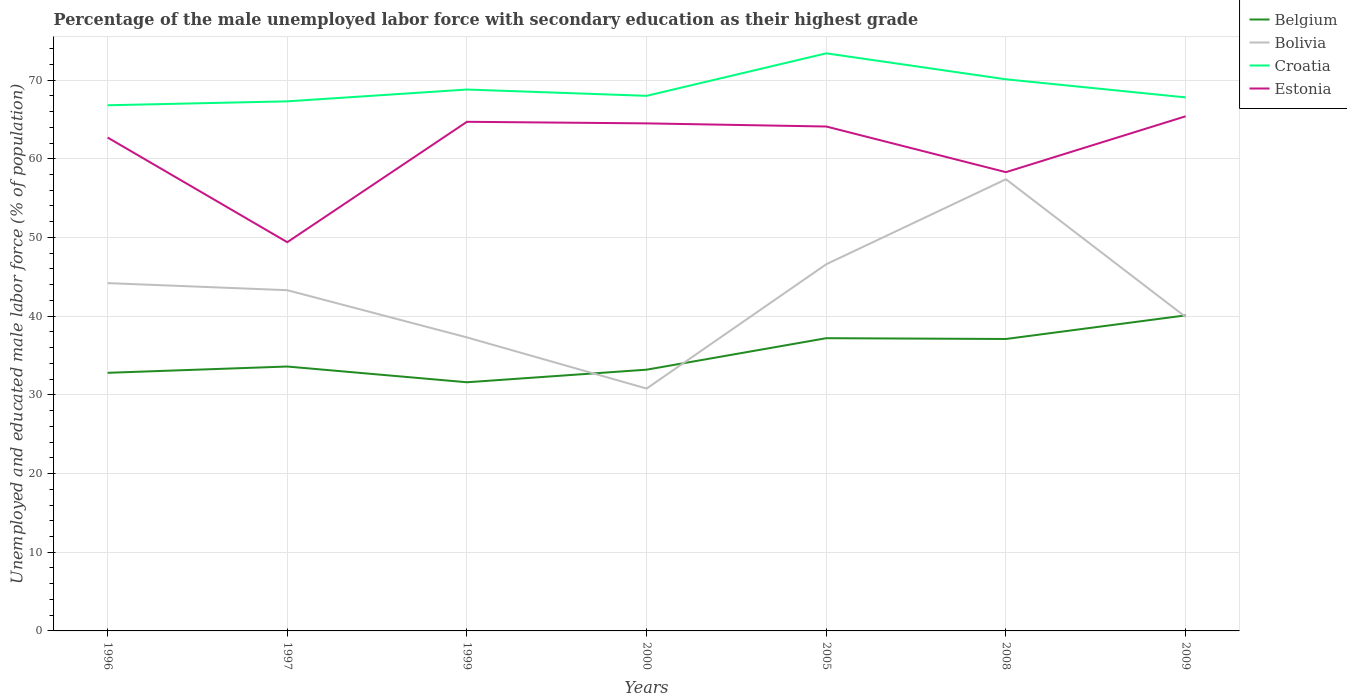Does the line corresponding to Estonia intersect with the line corresponding to Bolivia?
Keep it short and to the point. No. Across all years, what is the maximum percentage of the unemployed male labor force with secondary education in Bolivia?
Ensure brevity in your answer.  30.8. In which year was the percentage of the unemployed male labor force with secondary education in Belgium maximum?
Keep it short and to the point. 1999. What is the total percentage of the unemployed male labor force with secondary education in Belgium in the graph?
Keep it short and to the point. -7.3. What is the difference between the highest and the second highest percentage of the unemployed male labor force with secondary education in Bolivia?
Keep it short and to the point. 26.6. Is the percentage of the unemployed male labor force with secondary education in Belgium strictly greater than the percentage of the unemployed male labor force with secondary education in Croatia over the years?
Keep it short and to the point. Yes. How many lines are there?
Your answer should be compact. 4. How many years are there in the graph?
Provide a succinct answer. 7. What is the difference between two consecutive major ticks on the Y-axis?
Offer a very short reply. 10. What is the title of the graph?
Give a very brief answer. Percentage of the male unemployed labor force with secondary education as their highest grade. Does "Israel" appear as one of the legend labels in the graph?
Make the answer very short. No. What is the label or title of the Y-axis?
Keep it short and to the point. Unemployed and educated male labor force (% of population). What is the Unemployed and educated male labor force (% of population) of Belgium in 1996?
Your answer should be very brief. 32.8. What is the Unemployed and educated male labor force (% of population) in Bolivia in 1996?
Provide a short and direct response. 44.2. What is the Unemployed and educated male labor force (% of population) of Croatia in 1996?
Your answer should be very brief. 66.8. What is the Unemployed and educated male labor force (% of population) of Estonia in 1996?
Provide a succinct answer. 62.7. What is the Unemployed and educated male labor force (% of population) of Belgium in 1997?
Your response must be concise. 33.6. What is the Unemployed and educated male labor force (% of population) in Bolivia in 1997?
Offer a very short reply. 43.3. What is the Unemployed and educated male labor force (% of population) of Croatia in 1997?
Keep it short and to the point. 67.3. What is the Unemployed and educated male labor force (% of population) in Estonia in 1997?
Ensure brevity in your answer.  49.4. What is the Unemployed and educated male labor force (% of population) of Belgium in 1999?
Ensure brevity in your answer.  31.6. What is the Unemployed and educated male labor force (% of population) in Bolivia in 1999?
Provide a succinct answer. 37.3. What is the Unemployed and educated male labor force (% of population) in Croatia in 1999?
Provide a short and direct response. 68.8. What is the Unemployed and educated male labor force (% of population) in Estonia in 1999?
Your answer should be compact. 64.7. What is the Unemployed and educated male labor force (% of population) of Belgium in 2000?
Your answer should be very brief. 33.2. What is the Unemployed and educated male labor force (% of population) in Bolivia in 2000?
Offer a very short reply. 30.8. What is the Unemployed and educated male labor force (% of population) of Estonia in 2000?
Your answer should be compact. 64.5. What is the Unemployed and educated male labor force (% of population) of Belgium in 2005?
Offer a very short reply. 37.2. What is the Unemployed and educated male labor force (% of population) in Bolivia in 2005?
Your answer should be very brief. 46.6. What is the Unemployed and educated male labor force (% of population) in Croatia in 2005?
Make the answer very short. 73.4. What is the Unemployed and educated male labor force (% of population) of Estonia in 2005?
Your response must be concise. 64.1. What is the Unemployed and educated male labor force (% of population) in Belgium in 2008?
Your answer should be compact. 37.1. What is the Unemployed and educated male labor force (% of population) of Bolivia in 2008?
Keep it short and to the point. 57.4. What is the Unemployed and educated male labor force (% of population) of Croatia in 2008?
Provide a short and direct response. 70.1. What is the Unemployed and educated male labor force (% of population) in Estonia in 2008?
Provide a succinct answer. 58.3. What is the Unemployed and educated male labor force (% of population) of Belgium in 2009?
Keep it short and to the point. 40.1. What is the Unemployed and educated male labor force (% of population) in Bolivia in 2009?
Offer a terse response. 39.9. What is the Unemployed and educated male labor force (% of population) in Croatia in 2009?
Give a very brief answer. 67.8. What is the Unemployed and educated male labor force (% of population) of Estonia in 2009?
Ensure brevity in your answer.  65.4. Across all years, what is the maximum Unemployed and educated male labor force (% of population) of Belgium?
Make the answer very short. 40.1. Across all years, what is the maximum Unemployed and educated male labor force (% of population) in Bolivia?
Provide a succinct answer. 57.4. Across all years, what is the maximum Unemployed and educated male labor force (% of population) of Croatia?
Your response must be concise. 73.4. Across all years, what is the maximum Unemployed and educated male labor force (% of population) in Estonia?
Provide a succinct answer. 65.4. Across all years, what is the minimum Unemployed and educated male labor force (% of population) in Belgium?
Provide a succinct answer. 31.6. Across all years, what is the minimum Unemployed and educated male labor force (% of population) in Bolivia?
Give a very brief answer. 30.8. Across all years, what is the minimum Unemployed and educated male labor force (% of population) in Croatia?
Offer a very short reply. 66.8. Across all years, what is the minimum Unemployed and educated male labor force (% of population) in Estonia?
Ensure brevity in your answer.  49.4. What is the total Unemployed and educated male labor force (% of population) in Belgium in the graph?
Make the answer very short. 245.6. What is the total Unemployed and educated male labor force (% of population) of Bolivia in the graph?
Make the answer very short. 299.5. What is the total Unemployed and educated male labor force (% of population) in Croatia in the graph?
Provide a succinct answer. 482.2. What is the total Unemployed and educated male labor force (% of population) in Estonia in the graph?
Offer a terse response. 429.1. What is the difference between the Unemployed and educated male labor force (% of population) in Bolivia in 1996 and that in 1997?
Make the answer very short. 0.9. What is the difference between the Unemployed and educated male labor force (% of population) of Bolivia in 1996 and that in 1999?
Offer a very short reply. 6.9. What is the difference between the Unemployed and educated male labor force (% of population) in Croatia in 1996 and that in 1999?
Your answer should be compact. -2. What is the difference between the Unemployed and educated male labor force (% of population) of Belgium in 1996 and that in 2000?
Your answer should be very brief. -0.4. What is the difference between the Unemployed and educated male labor force (% of population) in Croatia in 1996 and that in 2000?
Offer a very short reply. -1.2. What is the difference between the Unemployed and educated male labor force (% of population) in Bolivia in 1996 and that in 2005?
Provide a short and direct response. -2.4. What is the difference between the Unemployed and educated male labor force (% of population) in Croatia in 1996 and that in 2008?
Offer a terse response. -3.3. What is the difference between the Unemployed and educated male labor force (% of population) of Estonia in 1996 and that in 2008?
Your response must be concise. 4.4. What is the difference between the Unemployed and educated male labor force (% of population) in Belgium in 1996 and that in 2009?
Provide a succinct answer. -7.3. What is the difference between the Unemployed and educated male labor force (% of population) in Belgium in 1997 and that in 1999?
Your response must be concise. 2. What is the difference between the Unemployed and educated male labor force (% of population) of Estonia in 1997 and that in 1999?
Offer a terse response. -15.3. What is the difference between the Unemployed and educated male labor force (% of population) of Estonia in 1997 and that in 2000?
Provide a short and direct response. -15.1. What is the difference between the Unemployed and educated male labor force (% of population) in Belgium in 1997 and that in 2005?
Ensure brevity in your answer.  -3.6. What is the difference between the Unemployed and educated male labor force (% of population) in Bolivia in 1997 and that in 2005?
Make the answer very short. -3.3. What is the difference between the Unemployed and educated male labor force (% of population) in Estonia in 1997 and that in 2005?
Offer a very short reply. -14.7. What is the difference between the Unemployed and educated male labor force (% of population) of Belgium in 1997 and that in 2008?
Your answer should be compact. -3.5. What is the difference between the Unemployed and educated male labor force (% of population) in Bolivia in 1997 and that in 2008?
Offer a terse response. -14.1. What is the difference between the Unemployed and educated male labor force (% of population) of Estonia in 1997 and that in 2008?
Provide a succinct answer. -8.9. What is the difference between the Unemployed and educated male labor force (% of population) of Belgium in 1999 and that in 2000?
Your answer should be compact. -1.6. What is the difference between the Unemployed and educated male labor force (% of population) of Estonia in 1999 and that in 2005?
Provide a succinct answer. 0.6. What is the difference between the Unemployed and educated male labor force (% of population) of Belgium in 1999 and that in 2008?
Offer a very short reply. -5.5. What is the difference between the Unemployed and educated male labor force (% of population) in Bolivia in 1999 and that in 2008?
Keep it short and to the point. -20.1. What is the difference between the Unemployed and educated male labor force (% of population) of Croatia in 1999 and that in 2008?
Your response must be concise. -1.3. What is the difference between the Unemployed and educated male labor force (% of population) of Estonia in 1999 and that in 2008?
Provide a succinct answer. 6.4. What is the difference between the Unemployed and educated male labor force (% of population) of Belgium in 1999 and that in 2009?
Provide a succinct answer. -8.5. What is the difference between the Unemployed and educated male labor force (% of population) of Belgium in 2000 and that in 2005?
Your answer should be compact. -4. What is the difference between the Unemployed and educated male labor force (% of population) in Bolivia in 2000 and that in 2005?
Offer a terse response. -15.8. What is the difference between the Unemployed and educated male labor force (% of population) in Croatia in 2000 and that in 2005?
Keep it short and to the point. -5.4. What is the difference between the Unemployed and educated male labor force (% of population) in Estonia in 2000 and that in 2005?
Your response must be concise. 0.4. What is the difference between the Unemployed and educated male labor force (% of population) in Belgium in 2000 and that in 2008?
Provide a short and direct response. -3.9. What is the difference between the Unemployed and educated male labor force (% of population) in Bolivia in 2000 and that in 2008?
Your answer should be very brief. -26.6. What is the difference between the Unemployed and educated male labor force (% of population) in Belgium in 2000 and that in 2009?
Provide a succinct answer. -6.9. What is the difference between the Unemployed and educated male labor force (% of population) of Estonia in 2000 and that in 2009?
Your response must be concise. -0.9. What is the difference between the Unemployed and educated male labor force (% of population) of Croatia in 2005 and that in 2008?
Offer a very short reply. 3.3. What is the difference between the Unemployed and educated male labor force (% of population) in Estonia in 2005 and that in 2008?
Your response must be concise. 5.8. What is the difference between the Unemployed and educated male labor force (% of population) of Belgium in 2005 and that in 2009?
Give a very brief answer. -2.9. What is the difference between the Unemployed and educated male labor force (% of population) of Bolivia in 2005 and that in 2009?
Provide a succinct answer. 6.7. What is the difference between the Unemployed and educated male labor force (% of population) in Estonia in 2005 and that in 2009?
Keep it short and to the point. -1.3. What is the difference between the Unemployed and educated male labor force (% of population) in Bolivia in 2008 and that in 2009?
Offer a very short reply. 17.5. What is the difference between the Unemployed and educated male labor force (% of population) in Croatia in 2008 and that in 2009?
Offer a terse response. 2.3. What is the difference between the Unemployed and educated male labor force (% of population) of Estonia in 2008 and that in 2009?
Make the answer very short. -7.1. What is the difference between the Unemployed and educated male labor force (% of population) in Belgium in 1996 and the Unemployed and educated male labor force (% of population) in Croatia in 1997?
Keep it short and to the point. -34.5. What is the difference between the Unemployed and educated male labor force (% of population) in Belgium in 1996 and the Unemployed and educated male labor force (% of population) in Estonia in 1997?
Provide a succinct answer. -16.6. What is the difference between the Unemployed and educated male labor force (% of population) of Bolivia in 1996 and the Unemployed and educated male labor force (% of population) of Croatia in 1997?
Provide a succinct answer. -23.1. What is the difference between the Unemployed and educated male labor force (% of population) of Bolivia in 1996 and the Unemployed and educated male labor force (% of population) of Estonia in 1997?
Keep it short and to the point. -5.2. What is the difference between the Unemployed and educated male labor force (% of population) of Belgium in 1996 and the Unemployed and educated male labor force (% of population) of Croatia in 1999?
Provide a short and direct response. -36. What is the difference between the Unemployed and educated male labor force (% of population) in Belgium in 1996 and the Unemployed and educated male labor force (% of population) in Estonia in 1999?
Your response must be concise. -31.9. What is the difference between the Unemployed and educated male labor force (% of population) in Bolivia in 1996 and the Unemployed and educated male labor force (% of population) in Croatia in 1999?
Offer a very short reply. -24.6. What is the difference between the Unemployed and educated male labor force (% of population) of Bolivia in 1996 and the Unemployed and educated male labor force (% of population) of Estonia in 1999?
Your answer should be very brief. -20.5. What is the difference between the Unemployed and educated male labor force (% of population) of Belgium in 1996 and the Unemployed and educated male labor force (% of population) of Croatia in 2000?
Ensure brevity in your answer.  -35.2. What is the difference between the Unemployed and educated male labor force (% of population) of Belgium in 1996 and the Unemployed and educated male labor force (% of population) of Estonia in 2000?
Offer a terse response. -31.7. What is the difference between the Unemployed and educated male labor force (% of population) of Bolivia in 1996 and the Unemployed and educated male labor force (% of population) of Croatia in 2000?
Give a very brief answer. -23.8. What is the difference between the Unemployed and educated male labor force (% of population) in Bolivia in 1996 and the Unemployed and educated male labor force (% of population) in Estonia in 2000?
Give a very brief answer. -20.3. What is the difference between the Unemployed and educated male labor force (% of population) of Belgium in 1996 and the Unemployed and educated male labor force (% of population) of Bolivia in 2005?
Provide a short and direct response. -13.8. What is the difference between the Unemployed and educated male labor force (% of population) in Belgium in 1996 and the Unemployed and educated male labor force (% of population) in Croatia in 2005?
Offer a very short reply. -40.6. What is the difference between the Unemployed and educated male labor force (% of population) of Belgium in 1996 and the Unemployed and educated male labor force (% of population) of Estonia in 2005?
Your response must be concise. -31.3. What is the difference between the Unemployed and educated male labor force (% of population) of Bolivia in 1996 and the Unemployed and educated male labor force (% of population) of Croatia in 2005?
Provide a succinct answer. -29.2. What is the difference between the Unemployed and educated male labor force (% of population) in Bolivia in 1996 and the Unemployed and educated male labor force (% of population) in Estonia in 2005?
Provide a short and direct response. -19.9. What is the difference between the Unemployed and educated male labor force (% of population) of Belgium in 1996 and the Unemployed and educated male labor force (% of population) of Bolivia in 2008?
Give a very brief answer. -24.6. What is the difference between the Unemployed and educated male labor force (% of population) in Belgium in 1996 and the Unemployed and educated male labor force (% of population) in Croatia in 2008?
Make the answer very short. -37.3. What is the difference between the Unemployed and educated male labor force (% of population) in Belgium in 1996 and the Unemployed and educated male labor force (% of population) in Estonia in 2008?
Provide a short and direct response. -25.5. What is the difference between the Unemployed and educated male labor force (% of population) of Bolivia in 1996 and the Unemployed and educated male labor force (% of population) of Croatia in 2008?
Keep it short and to the point. -25.9. What is the difference between the Unemployed and educated male labor force (% of population) in Bolivia in 1996 and the Unemployed and educated male labor force (% of population) in Estonia in 2008?
Your response must be concise. -14.1. What is the difference between the Unemployed and educated male labor force (% of population) of Belgium in 1996 and the Unemployed and educated male labor force (% of population) of Croatia in 2009?
Offer a terse response. -35. What is the difference between the Unemployed and educated male labor force (% of population) of Belgium in 1996 and the Unemployed and educated male labor force (% of population) of Estonia in 2009?
Make the answer very short. -32.6. What is the difference between the Unemployed and educated male labor force (% of population) of Bolivia in 1996 and the Unemployed and educated male labor force (% of population) of Croatia in 2009?
Make the answer very short. -23.6. What is the difference between the Unemployed and educated male labor force (% of population) of Bolivia in 1996 and the Unemployed and educated male labor force (% of population) of Estonia in 2009?
Your answer should be compact. -21.2. What is the difference between the Unemployed and educated male labor force (% of population) of Croatia in 1996 and the Unemployed and educated male labor force (% of population) of Estonia in 2009?
Provide a succinct answer. 1.4. What is the difference between the Unemployed and educated male labor force (% of population) of Belgium in 1997 and the Unemployed and educated male labor force (% of population) of Bolivia in 1999?
Keep it short and to the point. -3.7. What is the difference between the Unemployed and educated male labor force (% of population) in Belgium in 1997 and the Unemployed and educated male labor force (% of population) in Croatia in 1999?
Your answer should be compact. -35.2. What is the difference between the Unemployed and educated male labor force (% of population) of Belgium in 1997 and the Unemployed and educated male labor force (% of population) of Estonia in 1999?
Your response must be concise. -31.1. What is the difference between the Unemployed and educated male labor force (% of population) in Bolivia in 1997 and the Unemployed and educated male labor force (% of population) in Croatia in 1999?
Keep it short and to the point. -25.5. What is the difference between the Unemployed and educated male labor force (% of population) in Bolivia in 1997 and the Unemployed and educated male labor force (% of population) in Estonia in 1999?
Your response must be concise. -21.4. What is the difference between the Unemployed and educated male labor force (% of population) in Croatia in 1997 and the Unemployed and educated male labor force (% of population) in Estonia in 1999?
Offer a terse response. 2.6. What is the difference between the Unemployed and educated male labor force (% of population) of Belgium in 1997 and the Unemployed and educated male labor force (% of population) of Bolivia in 2000?
Offer a terse response. 2.8. What is the difference between the Unemployed and educated male labor force (% of population) of Belgium in 1997 and the Unemployed and educated male labor force (% of population) of Croatia in 2000?
Your answer should be very brief. -34.4. What is the difference between the Unemployed and educated male labor force (% of population) in Belgium in 1997 and the Unemployed and educated male labor force (% of population) in Estonia in 2000?
Your answer should be compact. -30.9. What is the difference between the Unemployed and educated male labor force (% of population) in Bolivia in 1997 and the Unemployed and educated male labor force (% of population) in Croatia in 2000?
Offer a very short reply. -24.7. What is the difference between the Unemployed and educated male labor force (% of population) of Bolivia in 1997 and the Unemployed and educated male labor force (% of population) of Estonia in 2000?
Offer a terse response. -21.2. What is the difference between the Unemployed and educated male labor force (% of population) in Croatia in 1997 and the Unemployed and educated male labor force (% of population) in Estonia in 2000?
Offer a very short reply. 2.8. What is the difference between the Unemployed and educated male labor force (% of population) in Belgium in 1997 and the Unemployed and educated male labor force (% of population) in Bolivia in 2005?
Ensure brevity in your answer.  -13. What is the difference between the Unemployed and educated male labor force (% of population) of Belgium in 1997 and the Unemployed and educated male labor force (% of population) of Croatia in 2005?
Provide a succinct answer. -39.8. What is the difference between the Unemployed and educated male labor force (% of population) of Belgium in 1997 and the Unemployed and educated male labor force (% of population) of Estonia in 2005?
Offer a very short reply. -30.5. What is the difference between the Unemployed and educated male labor force (% of population) of Bolivia in 1997 and the Unemployed and educated male labor force (% of population) of Croatia in 2005?
Your response must be concise. -30.1. What is the difference between the Unemployed and educated male labor force (% of population) of Bolivia in 1997 and the Unemployed and educated male labor force (% of population) of Estonia in 2005?
Make the answer very short. -20.8. What is the difference between the Unemployed and educated male labor force (% of population) in Croatia in 1997 and the Unemployed and educated male labor force (% of population) in Estonia in 2005?
Your answer should be compact. 3.2. What is the difference between the Unemployed and educated male labor force (% of population) of Belgium in 1997 and the Unemployed and educated male labor force (% of population) of Bolivia in 2008?
Your response must be concise. -23.8. What is the difference between the Unemployed and educated male labor force (% of population) in Belgium in 1997 and the Unemployed and educated male labor force (% of population) in Croatia in 2008?
Offer a terse response. -36.5. What is the difference between the Unemployed and educated male labor force (% of population) in Belgium in 1997 and the Unemployed and educated male labor force (% of population) in Estonia in 2008?
Your response must be concise. -24.7. What is the difference between the Unemployed and educated male labor force (% of population) in Bolivia in 1997 and the Unemployed and educated male labor force (% of population) in Croatia in 2008?
Keep it short and to the point. -26.8. What is the difference between the Unemployed and educated male labor force (% of population) in Belgium in 1997 and the Unemployed and educated male labor force (% of population) in Croatia in 2009?
Offer a very short reply. -34.2. What is the difference between the Unemployed and educated male labor force (% of population) of Belgium in 1997 and the Unemployed and educated male labor force (% of population) of Estonia in 2009?
Keep it short and to the point. -31.8. What is the difference between the Unemployed and educated male labor force (% of population) in Bolivia in 1997 and the Unemployed and educated male labor force (% of population) in Croatia in 2009?
Provide a short and direct response. -24.5. What is the difference between the Unemployed and educated male labor force (% of population) of Bolivia in 1997 and the Unemployed and educated male labor force (% of population) of Estonia in 2009?
Provide a short and direct response. -22.1. What is the difference between the Unemployed and educated male labor force (% of population) of Belgium in 1999 and the Unemployed and educated male labor force (% of population) of Croatia in 2000?
Offer a terse response. -36.4. What is the difference between the Unemployed and educated male labor force (% of population) of Belgium in 1999 and the Unemployed and educated male labor force (% of population) of Estonia in 2000?
Your answer should be compact. -32.9. What is the difference between the Unemployed and educated male labor force (% of population) in Bolivia in 1999 and the Unemployed and educated male labor force (% of population) in Croatia in 2000?
Offer a terse response. -30.7. What is the difference between the Unemployed and educated male labor force (% of population) in Bolivia in 1999 and the Unemployed and educated male labor force (% of population) in Estonia in 2000?
Offer a very short reply. -27.2. What is the difference between the Unemployed and educated male labor force (% of population) of Belgium in 1999 and the Unemployed and educated male labor force (% of population) of Croatia in 2005?
Provide a succinct answer. -41.8. What is the difference between the Unemployed and educated male labor force (% of population) in Belgium in 1999 and the Unemployed and educated male labor force (% of population) in Estonia in 2005?
Provide a short and direct response. -32.5. What is the difference between the Unemployed and educated male labor force (% of population) in Bolivia in 1999 and the Unemployed and educated male labor force (% of population) in Croatia in 2005?
Your response must be concise. -36.1. What is the difference between the Unemployed and educated male labor force (% of population) in Bolivia in 1999 and the Unemployed and educated male labor force (% of population) in Estonia in 2005?
Give a very brief answer. -26.8. What is the difference between the Unemployed and educated male labor force (% of population) of Belgium in 1999 and the Unemployed and educated male labor force (% of population) of Bolivia in 2008?
Give a very brief answer. -25.8. What is the difference between the Unemployed and educated male labor force (% of population) of Belgium in 1999 and the Unemployed and educated male labor force (% of population) of Croatia in 2008?
Your answer should be very brief. -38.5. What is the difference between the Unemployed and educated male labor force (% of population) in Belgium in 1999 and the Unemployed and educated male labor force (% of population) in Estonia in 2008?
Offer a terse response. -26.7. What is the difference between the Unemployed and educated male labor force (% of population) in Bolivia in 1999 and the Unemployed and educated male labor force (% of population) in Croatia in 2008?
Provide a succinct answer. -32.8. What is the difference between the Unemployed and educated male labor force (% of population) in Croatia in 1999 and the Unemployed and educated male labor force (% of population) in Estonia in 2008?
Give a very brief answer. 10.5. What is the difference between the Unemployed and educated male labor force (% of population) in Belgium in 1999 and the Unemployed and educated male labor force (% of population) in Bolivia in 2009?
Your answer should be very brief. -8.3. What is the difference between the Unemployed and educated male labor force (% of population) of Belgium in 1999 and the Unemployed and educated male labor force (% of population) of Croatia in 2009?
Provide a short and direct response. -36.2. What is the difference between the Unemployed and educated male labor force (% of population) of Belgium in 1999 and the Unemployed and educated male labor force (% of population) of Estonia in 2009?
Keep it short and to the point. -33.8. What is the difference between the Unemployed and educated male labor force (% of population) of Bolivia in 1999 and the Unemployed and educated male labor force (% of population) of Croatia in 2009?
Offer a terse response. -30.5. What is the difference between the Unemployed and educated male labor force (% of population) in Bolivia in 1999 and the Unemployed and educated male labor force (% of population) in Estonia in 2009?
Your answer should be compact. -28.1. What is the difference between the Unemployed and educated male labor force (% of population) of Croatia in 1999 and the Unemployed and educated male labor force (% of population) of Estonia in 2009?
Your response must be concise. 3.4. What is the difference between the Unemployed and educated male labor force (% of population) of Belgium in 2000 and the Unemployed and educated male labor force (% of population) of Bolivia in 2005?
Offer a terse response. -13.4. What is the difference between the Unemployed and educated male labor force (% of population) of Belgium in 2000 and the Unemployed and educated male labor force (% of population) of Croatia in 2005?
Make the answer very short. -40.2. What is the difference between the Unemployed and educated male labor force (% of population) of Belgium in 2000 and the Unemployed and educated male labor force (% of population) of Estonia in 2005?
Your answer should be very brief. -30.9. What is the difference between the Unemployed and educated male labor force (% of population) of Bolivia in 2000 and the Unemployed and educated male labor force (% of population) of Croatia in 2005?
Provide a short and direct response. -42.6. What is the difference between the Unemployed and educated male labor force (% of population) of Bolivia in 2000 and the Unemployed and educated male labor force (% of population) of Estonia in 2005?
Offer a terse response. -33.3. What is the difference between the Unemployed and educated male labor force (% of population) in Croatia in 2000 and the Unemployed and educated male labor force (% of population) in Estonia in 2005?
Your answer should be compact. 3.9. What is the difference between the Unemployed and educated male labor force (% of population) of Belgium in 2000 and the Unemployed and educated male labor force (% of population) of Bolivia in 2008?
Your response must be concise. -24.2. What is the difference between the Unemployed and educated male labor force (% of population) in Belgium in 2000 and the Unemployed and educated male labor force (% of population) in Croatia in 2008?
Offer a very short reply. -36.9. What is the difference between the Unemployed and educated male labor force (% of population) of Belgium in 2000 and the Unemployed and educated male labor force (% of population) of Estonia in 2008?
Give a very brief answer. -25.1. What is the difference between the Unemployed and educated male labor force (% of population) in Bolivia in 2000 and the Unemployed and educated male labor force (% of population) in Croatia in 2008?
Your answer should be compact. -39.3. What is the difference between the Unemployed and educated male labor force (% of population) of Bolivia in 2000 and the Unemployed and educated male labor force (% of population) of Estonia in 2008?
Your answer should be compact. -27.5. What is the difference between the Unemployed and educated male labor force (% of population) in Croatia in 2000 and the Unemployed and educated male labor force (% of population) in Estonia in 2008?
Your response must be concise. 9.7. What is the difference between the Unemployed and educated male labor force (% of population) in Belgium in 2000 and the Unemployed and educated male labor force (% of population) in Bolivia in 2009?
Your response must be concise. -6.7. What is the difference between the Unemployed and educated male labor force (% of population) in Belgium in 2000 and the Unemployed and educated male labor force (% of population) in Croatia in 2009?
Keep it short and to the point. -34.6. What is the difference between the Unemployed and educated male labor force (% of population) of Belgium in 2000 and the Unemployed and educated male labor force (% of population) of Estonia in 2009?
Offer a very short reply. -32.2. What is the difference between the Unemployed and educated male labor force (% of population) in Bolivia in 2000 and the Unemployed and educated male labor force (% of population) in Croatia in 2009?
Your answer should be compact. -37. What is the difference between the Unemployed and educated male labor force (% of population) of Bolivia in 2000 and the Unemployed and educated male labor force (% of population) of Estonia in 2009?
Your answer should be compact. -34.6. What is the difference between the Unemployed and educated male labor force (% of population) of Belgium in 2005 and the Unemployed and educated male labor force (% of population) of Bolivia in 2008?
Provide a succinct answer. -20.2. What is the difference between the Unemployed and educated male labor force (% of population) of Belgium in 2005 and the Unemployed and educated male labor force (% of population) of Croatia in 2008?
Ensure brevity in your answer.  -32.9. What is the difference between the Unemployed and educated male labor force (% of population) of Belgium in 2005 and the Unemployed and educated male labor force (% of population) of Estonia in 2008?
Offer a very short reply. -21.1. What is the difference between the Unemployed and educated male labor force (% of population) in Bolivia in 2005 and the Unemployed and educated male labor force (% of population) in Croatia in 2008?
Provide a short and direct response. -23.5. What is the difference between the Unemployed and educated male labor force (% of population) of Croatia in 2005 and the Unemployed and educated male labor force (% of population) of Estonia in 2008?
Give a very brief answer. 15.1. What is the difference between the Unemployed and educated male labor force (% of population) of Belgium in 2005 and the Unemployed and educated male labor force (% of population) of Bolivia in 2009?
Your answer should be compact. -2.7. What is the difference between the Unemployed and educated male labor force (% of population) of Belgium in 2005 and the Unemployed and educated male labor force (% of population) of Croatia in 2009?
Give a very brief answer. -30.6. What is the difference between the Unemployed and educated male labor force (% of population) in Belgium in 2005 and the Unemployed and educated male labor force (% of population) in Estonia in 2009?
Offer a very short reply. -28.2. What is the difference between the Unemployed and educated male labor force (% of population) in Bolivia in 2005 and the Unemployed and educated male labor force (% of population) in Croatia in 2009?
Keep it short and to the point. -21.2. What is the difference between the Unemployed and educated male labor force (% of population) of Bolivia in 2005 and the Unemployed and educated male labor force (% of population) of Estonia in 2009?
Ensure brevity in your answer.  -18.8. What is the difference between the Unemployed and educated male labor force (% of population) in Croatia in 2005 and the Unemployed and educated male labor force (% of population) in Estonia in 2009?
Ensure brevity in your answer.  8. What is the difference between the Unemployed and educated male labor force (% of population) in Belgium in 2008 and the Unemployed and educated male labor force (% of population) in Bolivia in 2009?
Ensure brevity in your answer.  -2.8. What is the difference between the Unemployed and educated male labor force (% of population) of Belgium in 2008 and the Unemployed and educated male labor force (% of population) of Croatia in 2009?
Ensure brevity in your answer.  -30.7. What is the difference between the Unemployed and educated male labor force (% of population) in Belgium in 2008 and the Unemployed and educated male labor force (% of population) in Estonia in 2009?
Your answer should be compact. -28.3. What is the difference between the Unemployed and educated male labor force (% of population) in Bolivia in 2008 and the Unemployed and educated male labor force (% of population) in Croatia in 2009?
Ensure brevity in your answer.  -10.4. What is the difference between the Unemployed and educated male labor force (% of population) of Bolivia in 2008 and the Unemployed and educated male labor force (% of population) of Estonia in 2009?
Your answer should be compact. -8. What is the difference between the Unemployed and educated male labor force (% of population) of Croatia in 2008 and the Unemployed and educated male labor force (% of population) of Estonia in 2009?
Keep it short and to the point. 4.7. What is the average Unemployed and educated male labor force (% of population) of Belgium per year?
Ensure brevity in your answer.  35.09. What is the average Unemployed and educated male labor force (% of population) of Bolivia per year?
Provide a short and direct response. 42.79. What is the average Unemployed and educated male labor force (% of population) of Croatia per year?
Provide a succinct answer. 68.89. What is the average Unemployed and educated male labor force (% of population) of Estonia per year?
Provide a short and direct response. 61.3. In the year 1996, what is the difference between the Unemployed and educated male labor force (% of population) of Belgium and Unemployed and educated male labor force (% of population) of Bolivia?
Make the answer very short. -11.4. In the year 1996, what is the difference between the Unemployed and educated male labor force (% of population) in Belgium and Unemployed and educated male labor force (% of population) in Croatia?
Your answer should be very brief. -34. In the year 1996, what is the difference between the Unemployed and educated male labor force (% of population) in Belgium and Unemployed and educated male labor force (% of population) in Estonia?
Your answer should be very brief. -29.9. In the year 1996, what is the difference between the Unemployed and educated male labor force (% of population) of Bolivia and Unemployed and educated male labor force (% of population) of Croatia?
Your answer should be very brief. -22.6. In the year 1996, what is the difference between the Unemployed and educated male labor force (% of population) in Bolivia and Unemployed and educated male labor force (% of population) in Estonia?
Provide a succinct answer. -18.5. In the year 1996, what is the difference between the Unemployed and educated male labor force (% of population) in Croatia and Unemployed and educated male labor force (% of population) in Estonia?
Provide a succinct answer. 4.1. In the year 1997, what is the difference between the Unemployed and educated male labor force (% of population) in Belgium and Unemployed and educated male labor force (% of population) in Bolivia?
Your answer should be very brief. -9.7. In the year 1997, what is the difference between the Unemployed and educated male labor force (% of population) of Belgium and Unemployed and educated male labor force (% of population) of Croatia?
Make the answer very short. -33.7. In the year 1997, what is the difference between the Unemployed and educated male labor force (% of population) in Belgium and Unemployed and educated male labor force (% of population) in Estonia?
Keep it short and to the point. -15.8. In the year 1999, what is the difference between the Unemployed and educated male labor force (% of population) in Belgium and Unemployed and educated male labor force (% of population) in Croatia?
Keep it short and to the point. -37.2. In the year 1999, what is the difference between the Unemployed and educated male labor force (% of population) in Belgium and Unemployed and educated male labor force (% of population) in Estonia?
Your answer should be very brief. -33.1. In the year 1999, what is the difference between the Unemployed and educated male labor force (% of population) of Bolivia and Unemployed and educated male labor force (% of population) of Croatia?
Ensure brevity in your answer.  -31.5. In the year 1999, what is the difference between the Unemployed and educated male labor force (% of population) in Bolivia and Unemployed and educated male labor force (% of population) in Estonia?
Your answer should be very brief. -27.4. In the year 1999, what is the difference between the Unemployed and educated male labor force (% of population) in Croatia and Unemployed and educated male labor force (% of population) in Estonia?
Provide a short and direct response. 4.1. In the year 2000, what is the difference between the Unemployed and educated male labor force (% of population) in Belgium and Unemployed and educated male labor force (% of population) in Croatia?
Provide a succinct answer. -34.8. In the year 2000, what is the difference between the Unemployed and educated male labor force (% of population) in Belgium and Unemployed and educated male labor force (% of population) in Estonia?
Give a very brief answer. -31.3. In the year 2000, what is the difference between the Unemployed and educated male labor force (% of population) in Bolivia and Unemployed and educated male labor force (% of population) in Croatia?
Offer a very short reply. -37.2. In the year 2000, what is the difference between the Unemployed and educated male labor force (% of population) of Bolivia and Unemployed and educated male labor force (% of population) of Estonia?
Your answer should be very brief. -33.7. In the year 2005, what is the difference between the Unemployed and educated male labor force (% of population) of Belgium and Unemployed and educated male labor force (% of population) of Bolivia?
Offer a very short reply. -9.4. In the year 2005, what is the difference between the Unemployed and educated male labor force (% of population) of Belgium and Unemployed and educated male labor force (% of population) of Croatia?
Give a very brief answer. -36.2. In the year 2005, what is the difference between the Unemployed and educated male labor force (% of population) in Belgium and Unemployed and educated male labor force (% of population) in Estonia?
Keep it short and to the point. -26.9. In the year 2005, what is the difference between the Unemployed and educated male labor force (% of population) in Bolivia and Unemployed and educated male labor force (% of population) in Croatia?
Provide a short and direct response. -26.8. In the year 2005, what is the difference between the Unemployed and educated male labor force (% of population) in Bolivia and Unemployed and educated male labor force (% of population) in Estonia?
Your answer should be very brief. -17.5. In the year 2008, what is the difference between the Unemployed and educated male labor force (% of population) of Belgium and Unemployed and educated male labor force (% of population) of Bolivia?
Provide a succinct answer. -20.3. In the year 2008, what is the difference between the Unemployed and educated male labor force (% of population) in Belgium and Unemployed and educated male labor force (% of population) in Croatia?
Keep it short and to the point. -33. In the year 2008, what is the difference between the Unemployed and educated male labor force (% of population) in Belgium and Unemployed and educated male labor force (% of population) in Estonia?
Offer a terse response. -21.2. In the year 2009, what is the difference between the Unemployed and educated male labor force (% of population) in Belgium and Unemployed and educated male labor force (% of population) in Bolivia?
Give a very brief answer. 0.2. In the year 2009, what is the difference between the Unemployed and educated male labor force (% of population) of Belgium and Unemployed and educated male labor force (% of population) of Croatia?
Provide a short and direct response. -27.7. In the year 2009, what is the difference between the Unemployed and educated male labor force (% of population) in Belgium and Unemployed and educated male labor force (% of population) in Estonia?
Give a very brief answer. -25.3. In the year 2009, what is the difference between the Unemployed and educated male labor force (% of population) in Bolivia and Unemployed and educated male labor force (% of population) in Croatia?
Give a very brief answer. -27.9. In the year 2009, what is the difference between the Unemployed and educated male labor force (% of population) in Bolivia and Unemployed and educated male labor force (% of population) in Estonia?
Give a very brief answer. -25.5. What is the ratio of the Unemployed and educated male labor force (% of population) in Belgium in 1996 to that in 1997?
Your response must be concise. 0.98. What is the ratio of the Unemployed and educated male labor force (% of population) in Bolivia in 1996 to that in 1997?
Give a very brief answer. 1.02. What is the ratio of the Unemployed and educated male labor force (% of population) of Croatia in 1996 to that in 1997?
Your response must be concise. 0.99. What is the ratio of the Unemployed and educated male labor force (% of population) of Estonia in 1996 to that in 1997?
Provide a short and direct response. 1.27. What is the ratio of the Unemployed and educated male labor force (% of population) of Belgium in 1996 to that in 1999?
Your response must be concise. 1.04. What is the ratio of the Unemployed and educated male labor force (% of population) of Bolivia in 1996 to that in 1999?
Offer a terse response. 1.19. What is the ratio of the Unemployed and educated male labor force (% of population) in Croatia in 1996 to that in 1999?
Your answer should be compact. 0.97. What is the ratio of the Unemployed and educated male labor force (% of population) of Estonia in 1996 to that in 1999?
Your response must be concise. 0.97. What is the ratio of the Unemployed and educated male labor force (% of population) of Belgium in 1996 to that in 2000?
Provide a succinct answer. 0.99. What is the ratio of the Unemployed and educated male labor force (% of population) of Bolivia in 1996 to that in 2000?
Give a very brief answer. 1.44. What is the ratio of the Unemployed and educated male labor force (% of population) in Croatia in 1996 to that in 2000?
Provide a succinct answer. 0.98. What is the ratio of the Unemployed and educated male labor force (% of population) of Estonia in 1996 to that in 2000?
Keep it short and to the point. 0.97. What is the ratio of the Unemployed and educated male labor force (% of population) in Belgium in 1996 to that in 2005?
Keep it short and to the point. 0.88. What is the ratio of the Unemployed and educated male labor force (% of population) in Bolivia in 1996 to that in 2005?
Offer a very short reply. 0.95. What is the ratio of the Unemployed and educated male labor force (% of population) of Croatia in 1996 to that in 2005?
Provide a short and direct response. 0.91. What is the ratio of the Unemployed and educated male labor force (% of population) in Estonia in 1996 to that in 2005?
Offer a very short reply. 0.98. What is the ratio of the Unemployed and educated male labor force (% of population) of Belgium in 1996 to that in 2008?
Ensure brevity in your answer.  0.88. What is the ratio of the Unemployed and educated male labor force (% of population) of Bolivia in 1996 to that in 2008?
Your answer should be compact. 0.77. What is the ratio of the Unemployed and educated male labor force (% of population) in Croatia in 1996 to that in 2008?
Offer a terse response. 0.95. What is the ratio of the Unemployed and educated male labor force (% of population) in Estonia in 1996 to that in 2008?
Make the answer very short. 1.08. What is the ratio of the Unemployed and educated male labor force (% of population) of Belgium in 1996 to that in 2009?
Ensure brevity in your answer.  0.82. What is the ratio of the Unemployed and educated male labor force (% of population) in Bolivia in 1996 to that in 2009?
Your answer should be compact. 1.11. What is the ratio of the Unemployed and educated male labor force (% of population) in Estonia in 1996 to that in 2009?
Give a very brief answer. 0.96. What is the ratio of the Unemployed and educated male labor force (% of population) of Belgium in 1997 to that in 1999?
Your response must be concise. 1.06. What is the ratio of the Unemployed and educated male labor force (% of population) in Bolivia in 1997 to that in 1999?
Ensure brevity in your answer.  1.16. What is the ratio of the Unemployed and educated male labor force (% of population) of Croatia in 1997 to that in 1999?
Your answer should be very brief. 0.98. What is the ratio of the Unemployed and educated male labor force (% of population) in Estonia in 1997 to that in 1999?
Your response must be concise. 0.76. What is the ratio of the Unemployed and educated male labor force (% of population) of Bolivia in 1997 to that in 2000?
Provide a succinct answer. 1.41. What is the ratio of the Unemployed and educated male labor force (% of population) in Estonia in 1997 to that in 2000?
Provide a succinct answer. 0.77. What is the ratio of the Unemployed and educated male labor force (% of population) in Belgium in 1997 to that in 2005?
Ensure brevity in your answer.  0.9. What is the ratio of the Unemployed and educated male labor force (% of population) in Bolivia in 1997 to that in 2005?
Your answer should be compact. 0.93. What is the ratio of the Unemployed and educated male labor force (% of population) in Croatia in 1997 to that in 2005?
Keep it short and to the point. 0.92. What is the ratio of the Unemployed and educated male labor force (% of population) of Estonia in 1997 to that in 2005?
Your answer should be compact. 0.77. What is the ratio of the Unemployed and educated male labor force (% of population) of Belgium in 1997 to that in 2008?
Give a very brief answer. 0.91. What is the ratio of the Unemployed and educated male labor force (% of population) of Bolivia in 1997 to that in 2008?
Ensure brevity in your answer.  0.75. What is the ratio of the Unemployed and educated male labor force (% of population) of Croatia in 1997 to that in 2008?
Provide a short and direct response. 0.96. What is the ratio of the Unemployed and educated male labor force (% of population) in Estonia in 1997 to that in 2008?
Ensure brevity in your answer.  0.85. What is the ratio of the Unemployed and educated male labor force (% of population) in Belgium in 1997 to that in 2009?
Your answer should be compact. 0.84. What is the ratio of the Unemployed and educated male labor force (% of population) of Bolivia in 1997 to that in 2009?
Your response must be concise. 1.09. What is the ratio of the Unemployed and educated male labor force (% of population) of Croatia in 1997 to that in 2009?
Your response must be concise. 0.99. What is the ratio of the Unemployed and educated male labor force (% of population) in Estonia in 1997 to that in 2009?
Ensure brevity in your answer.  0.76. What is the ratio of the Unemployed and educated male labor force (% of population) in Belgium in 1999 to that in 2000?
Make the answer very short. 0.95. What is the ratio of the Unemployed and educated male labor force (% of population) in Bolivia in 1999 to that in 2000?
Ensure brevity in your answer.  1.21. What is the ratio of the Unemployed and educated male labor force (% of population) in Croatia in 1999 to that in 2000?
Provide a short and direct response. 1.01. What is the ratio of the Unemployed and educated male labor force (% of population) of Estonia in 1999 to that in 2000?
Keep it short and to the point. 1. What is the ratio of the Unemployed and educated male labor force (% of population) of Belgium in 1999 to that in 2005?
Provide a short and direct response. 0.85. What is the ratio of the Unemployed and educated male labor force (% of population) of Bolivia in 1999 to that in 2005?
Ensure brevity in your answer.  0.8. What is the ratio of the Unemployed and educated male labor force (% of population) in Croatia in 1999 to that in 2005?
Your answer should be very brief. 0.94. What is the ratio of the Unemployed and educated male labor force (% of population) of Estonia in 1999 to that in 2005?
Your response must be concise. 1.01. What is the ratio of the Unemployed and educated male labor force (% of population) of Belgium in 1999 to that in 2008?
Offer a terse response. 0.85. What is the ratio of the Unemployed and educated male labor force (% of population) of Bolivia in 1999 to that in 2008?
Your answer should be compact. 0.65. What is the ratio of the Unemployed and educated male labor force (% of population) of Croatia in 1999 to that in 2008?
Offer a terse response. 0.98. What is the ratio of the Unemployed and educated male labor force (% of population) of Estonia in 1999 to that in 2008?
Make the answer very short. 1.11. What is the ratio of the Unemployed and educated male labor force (% of population) of Belgium in 1999 to that in 2009?
Keep it short and to the point. 0.79. What is the ratio of the Unemployed and educated male labor force (% of population) in Bolivia in 1999 to that in 2009?
Your response must be concise. 0.93. What is the ratio of the Unemployed and educated male labor force (% of population) of Croatia in 1999 to that in 2009?
Your answer should be very brief. 1.01. What is the ratio of the Unemployed and educated male labor force (% of population) of Estonia in 1999 to that in 2009?
Provide a succinct answer. 0.99. What is the ratio of the Unemployed and educated male labor force (% of population) in Belgium in 2000 to that in 2005?
Your answer should be compact. 0.89. What is the ratio of the Unemployed and educated male labor force (% of population) of Bolivia in 2000 to that in 2005?
Your answer should be very brief. 0.66. What is the ratio of the Unemployed and educated male labor force (% of population) of Croatia in 2000 to that in 2005?
Offer a terse response. 0.93. What is the ratio of the Unemployed and educated male labor force (% of population) in Estonia in 2000 to that in 2005?
Your answer should be compact. 1.01. What is the ratio of the Unemployed and educated male labor force (% of population) in Belgium in 2000 to that in 2008?
Your answer should be compact. 0.89. What is the ratio of the Unemployed and educated male labor force (% of population) in Bolivia in 2000 to that in 2008?
Give a very brief answer. 0.54. What is the ratio of the Unemployed and educated male labor force (% of population) in Croatia in 2000 to that in 2008?
Make the answer very short. 0.97. What is the ratio of the Unemployed and educated male labor force (% of population) of Estonia in 2000 to that in 2008?
Your response must be concise. 1.11. What is the ratio of the Unemployed and educated male labor force (% of population) of Belgium in 2000 to that in 2009?
Keep it short and to the point. 0.83. What is the ratio of the Unemployed and educated male labor force (% of population) of Bolivia in 2000 to that in 2009?
Ensure brevity in your answer.  0.77. What is the ratio of the Unemployed and educated male labor force (% of population) in Croatia in 2000 to that in 2009?
Offer a very short reply. 1. What is the ratio of the Unemployed and educated male labor force (% of population) in Estonia in 2000 to that in 2009?
Your answer should be very brief. 0.99. What is the ratio of the Unemployed and educated male labor force (% of population) in Bolivia in 2005 to that in 2008?
Your answer should be very brief. 0.81. What is the ratio of the Unemployed and educated male labor force (% of population) of Croatia in 2005 to that in 2008?
Make the answer very short. 1.05. What is the ratio of the Unemployed and educated male labor force (% of population) of Estonia in 2005 to that in 2008?
Offer a very short reply. 1.1. What is the ratio of the Unemployed and educated male labor force (% of population) in Belgium in 2005 to that in 2009?
Keep it short and to the point. 0.93. What is the ratio of the Unemployed and educated male labor force (% of population) of Bolivia in 2005 to that in 2009?
Make the answer very short. 1.17. What is the ratio of the Unemployed and educated male labor force (% of population) of Croatia in 2005 to that in 2009?
Your response must be concise. 1.08. What is the ratio of the Unemployed and educated male labor force (% of population) of Estonia in 2005 to that in 2009?
Your answer should be compact. 0.98. What is the ratio of the Unemployed and educated male labor force (% of population) in Belgium in 2008 to that in 2009?
Provide a short and direct response. 0.93. What is the ratio of the Unemployed and educated male labor force (% of population) in Bolivia in 2008 to that in 2009?
Keep it short and to the point. 1.44. What is the ratio of the Unemployed and educated male labor force (% of population) in Croatia in 2008 to that in 2009?
Keep it short and to the point. 1.03. What is the ratio of the Unemployed and educated male labor force (% of population) of Estonia in 2008 to that in 2009?
Make the answer very short. 0.89. What is the difference between the highest and the second highest Unemployed and educated male labor force (% of population) of Croatia?
Your answer should be very brief. 3.3. What is the difference between the highest and the lowest Unemployed and educated male labor force (% of population) in Belgium?
Your answer should be very brief. 8.5. What is the difference between the highest and the lowest Unemployed and educated male labor force (% of population) in Bolivia?
Make the answer very short. 26.6. What is the difference between the highest and the lowest Unemployed and educated male labor force (% of population) of Estonia?
Give a very brief answer. 16. 